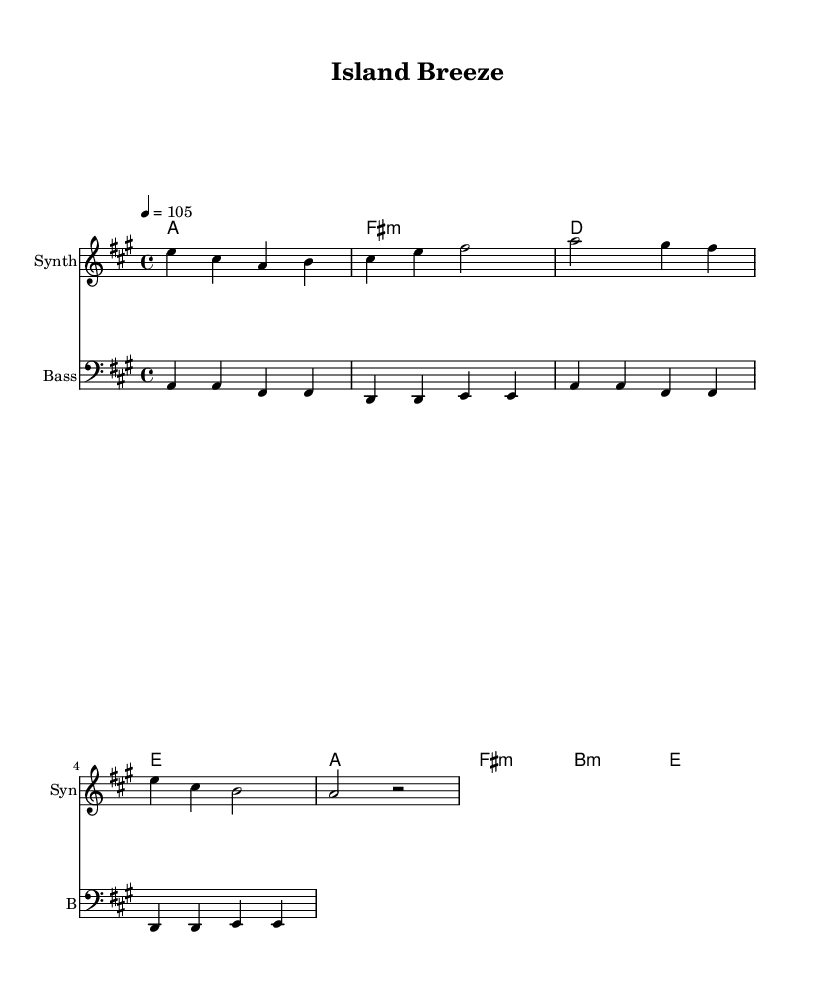What is the key signature of this music? The key signature contains three sharps, indicating that the piece is in A major. This is confirmed by the presence of the sharp symbols placed on the F#, C#, and G# lines in the standard key signature representation.
Answer: A major What is the time signature of this music? The time signature is displayed as 4/4 at the beginning of the score. This means there are four beats in each measure, and a quarter note gets one beat, which is a standard for many dance music styles.
Answer: 4/4 What is the tempo marking of this piece? The tempo marking indicates a speed of 105 BPM (beats per minute), placed at the start of the score. This indicates that the music should be played at a moderate pace, suitable for relaxing beach vibes.
Answer: 105 How many measures are there in the melody? By counting the measures in the melody line, we can see there are a total of 7 measures, indicated by the bar lines separating each segment of the melody.
Answer: 7 Which chords are used in the harmonies section? The harmonies section includes the chords A major, F# minor, D major, and E major, as they are explicitly written out in chord symbols above the melody line.
Answer: A, F# minor, D, E What kind of instrument is playing the melody? The melody is played by a 'Synth', as noted in the staff header of the score. This indicates that a synthesizer synthesizes sound to create the melody line, which is typical in dance music.
Answer: Synth What is the bass note that plays in the first measure? The bass note in the first measure is A, as indicated by the note on the bass staff, which is also reinforced with the chord name A major in the harmonies section.
Answer: A 